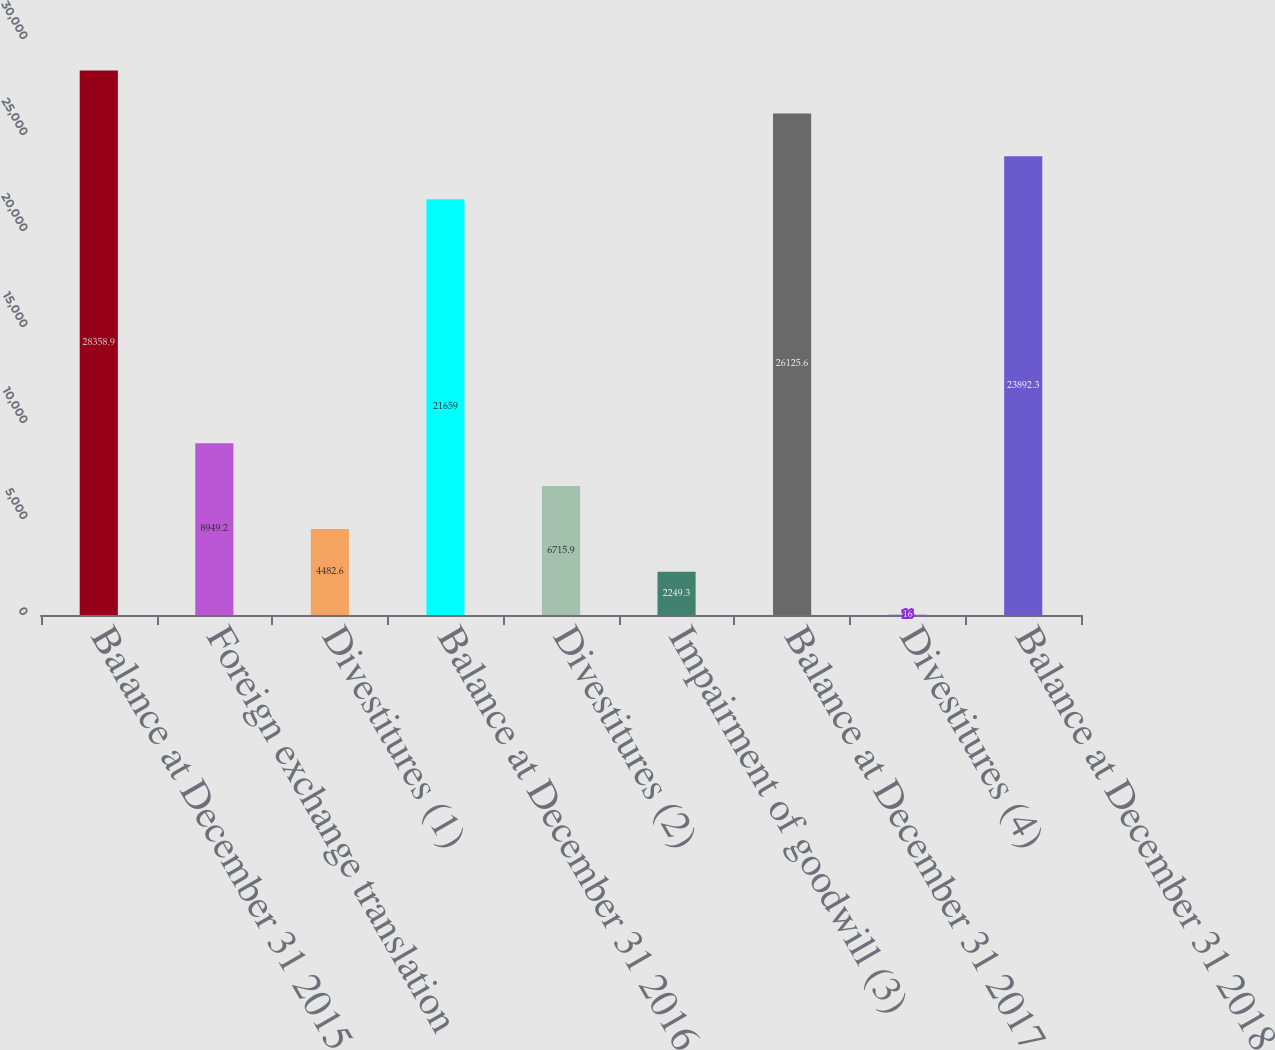Convert chart to OTSL. <chart><loc_0><loc_0><loc_500><loc_500><bar_chart><fcel>Balance at December 31 2015<fcel>Foreign exchange translation<fcel>Divestitures (1)<fcel>Balance at December 31 2016<fcel>Divestitures (2)<fcel>Impairment of goodwill (3)<fcel>Balance at December 31 2017<fcel>Divestitures (4)<fcel>Balance at December 31 2018<nl><fcel>28358.9<fcel>8949.2<fcel>4482.6<fcel>21659<fcel>6715.9<fcel>2249.3<fcel>26125.6<fcel>16<fcel>23892.3<nl></chart> 